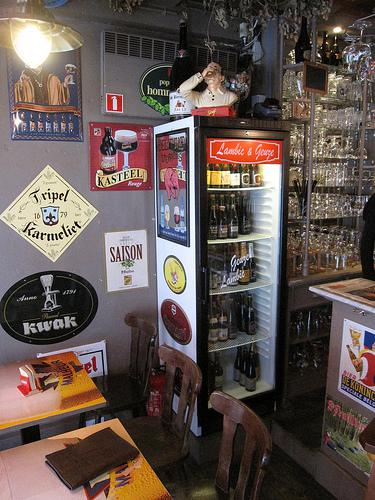Question: who took this picture?
Choices:
A. A person at home.
B. A person in a bar.
C. A person in a park.
D. A person on the street.
Answer with the letter. Answer: B Question: when was the picture taken?
Choices:
A. In the morning.
B. In the afternoon.
C. At night.
D. At sunrise.
Answer with the letter. Answer: C Question: why are there glasses in the shelf?
Choices:
A. For food.
B. For decoration.
C. For drinks.
D. For safety.
Answer with the letter. Answer: C Question: what does the black sign say?
Choices:
A. Quick.
B. Kwak.
C. Clock.
D. Cluck.
Answer with the letter. Answer: B Question: how many chairs are visible?
Choices:
A. 7.
B. 3.
C. 8.
D. 9.
Answer with the letter. Answer: B 